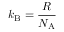Convert formula to latex. <formula><loc_0><loc_0><loc_500><loc_500>k _ { B } = { \frac { R } { N _ { A } } }</formula> 